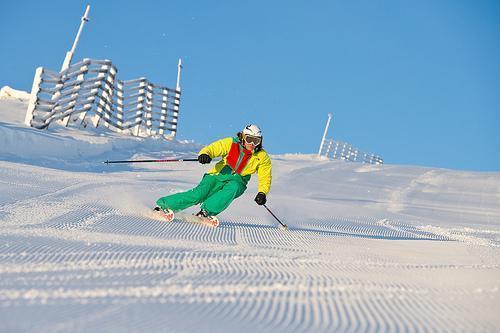How many people are skiing?
Give a very brief answer. 1. 